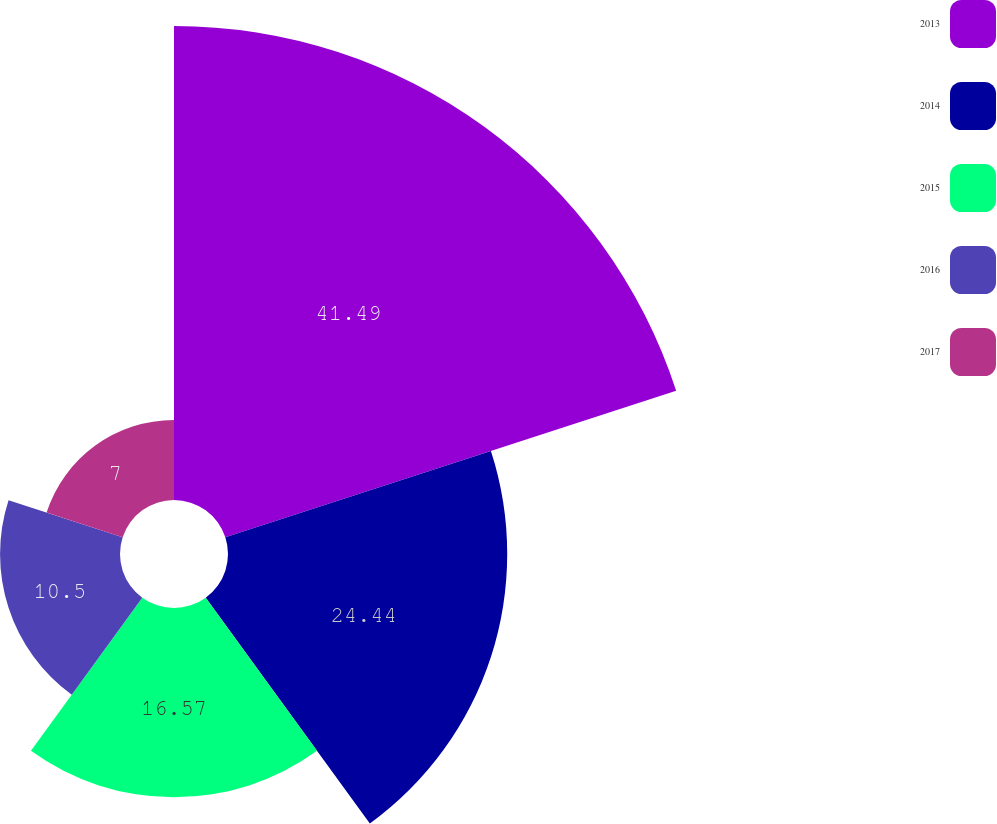Convert chart to OTSL. <chart><loc_0><loc_0><loc_500><loc_500><pie_chart><fcel>2013<fcel>2014<fcel>2015<fcel>2016<fcel>2017<nl><fcel>41.49%<fcel>24.44%<fcel>16.57%<fcel>10.5%<fcel>7.0%<nl></chart> 